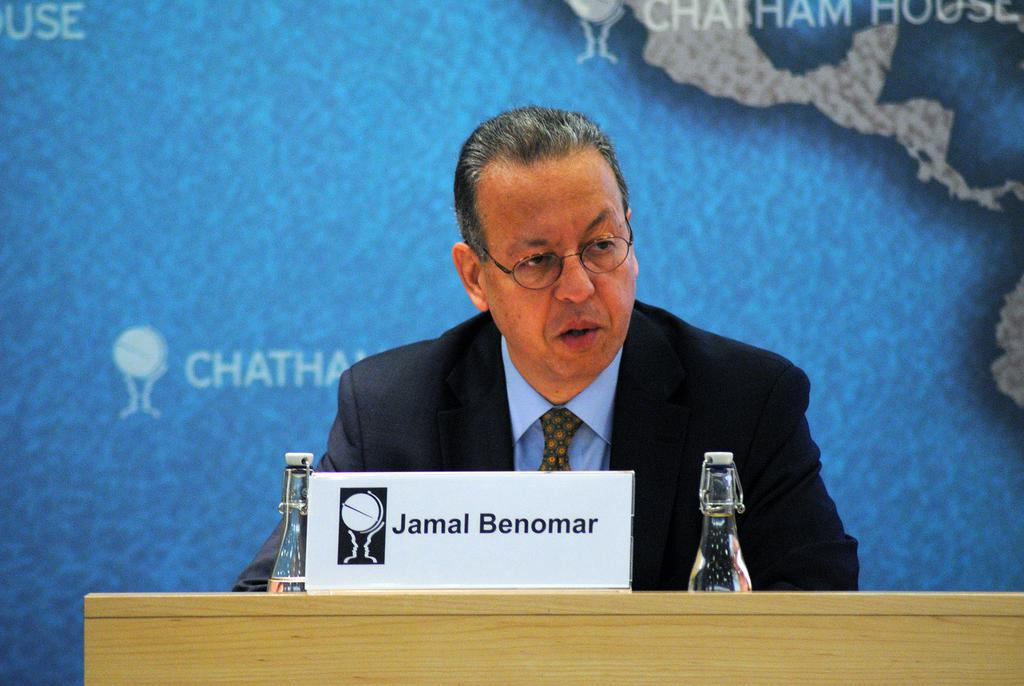What is located at the bottom of the image? There is a table at the bottom of the image. What items can be seen on the table? There are bottles and a banner on the table. Who is present in the image? A person is standing behind the table. What is visible behind the person? There is a banner behind the person. Can you tell me how many bees are buzzing around the bottles in the image? There are no bees present in the image; it only features bottles, a banner, and a person standing behind the table. 